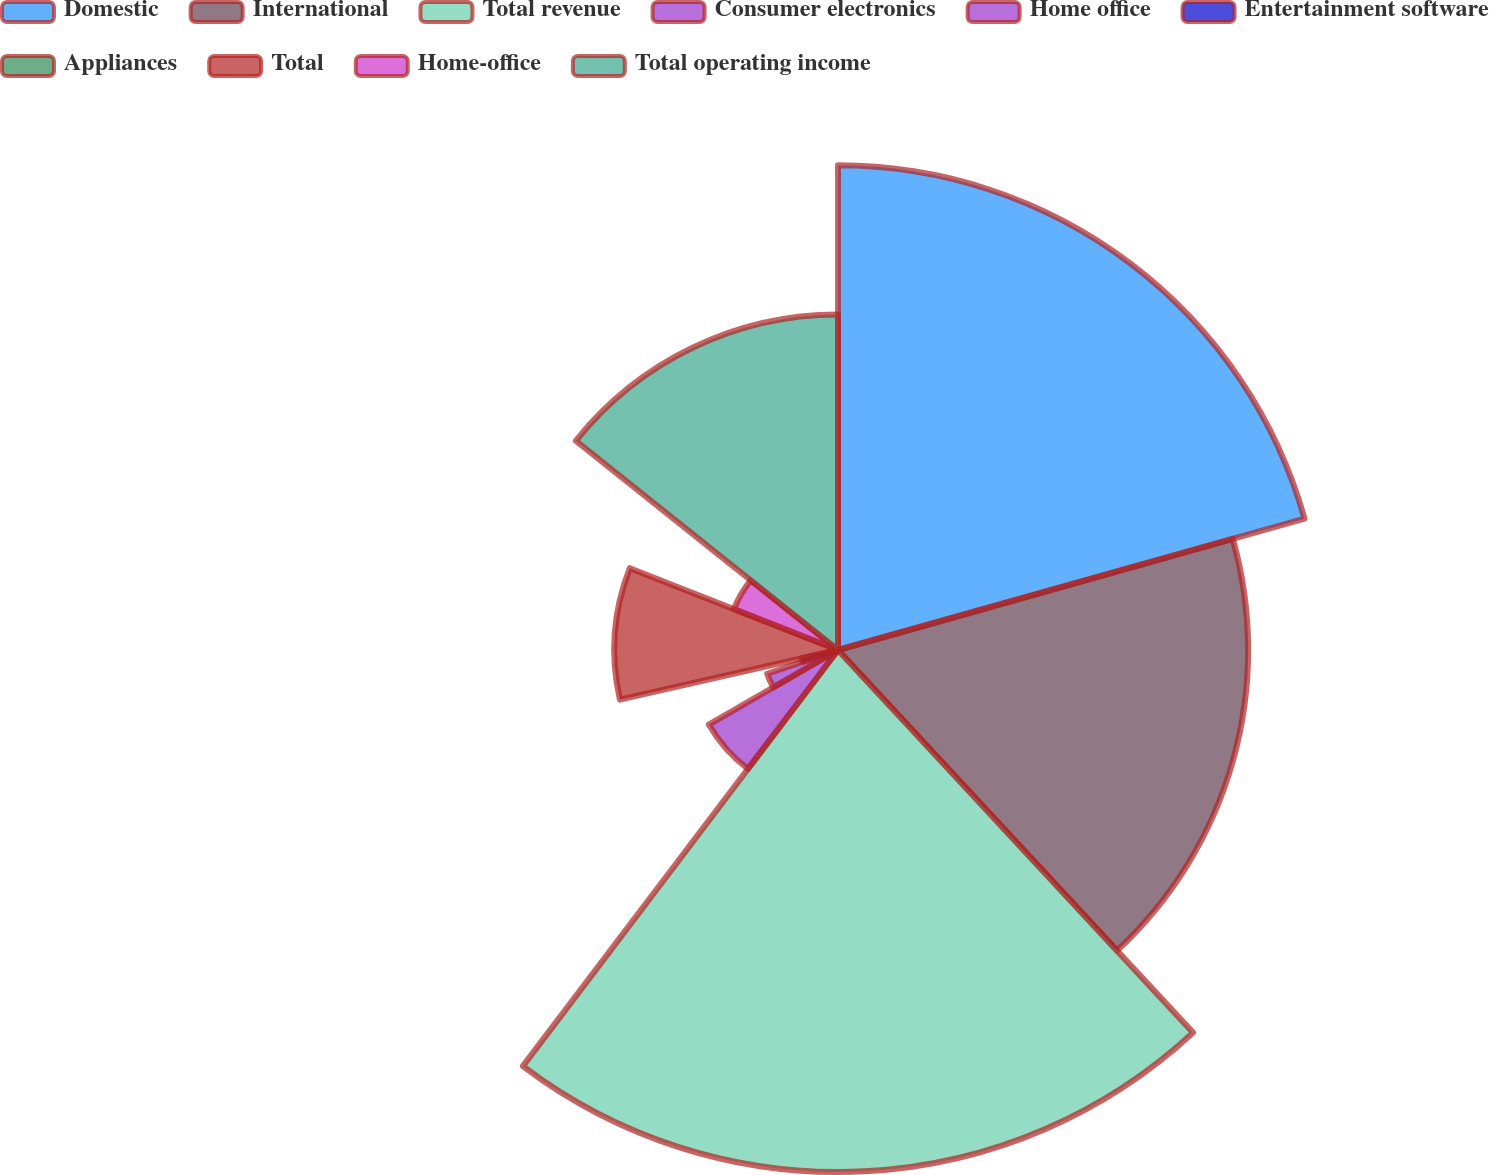<chart> <loc_0><loc_0><loc_500><loc_500><pie_chart><fcel>Domestic<fcel>International<fcel>Total revenue<fcel>Consumer electronics<fcel>Home office<fcel>Entertainment software<fcel>Appliances<fcel>Total<fcel>Home-office<fcel>Total operating income<nl><fcel>20.63%<fcel>17.46%<fcel>22.22%<fcel>6.35%<fcel>3.18%<fcel>1.59%<fcel>0.0%<fcel>9.52%<fcel>4.76%<fcel>14.28%<nl></chart> 